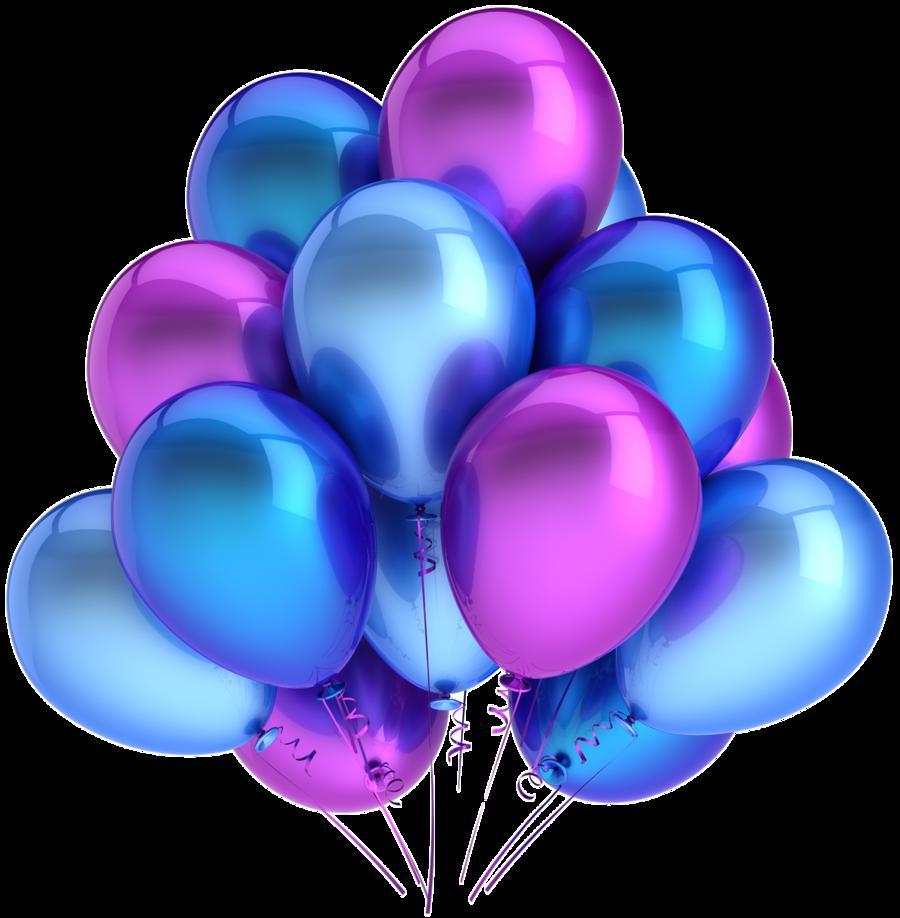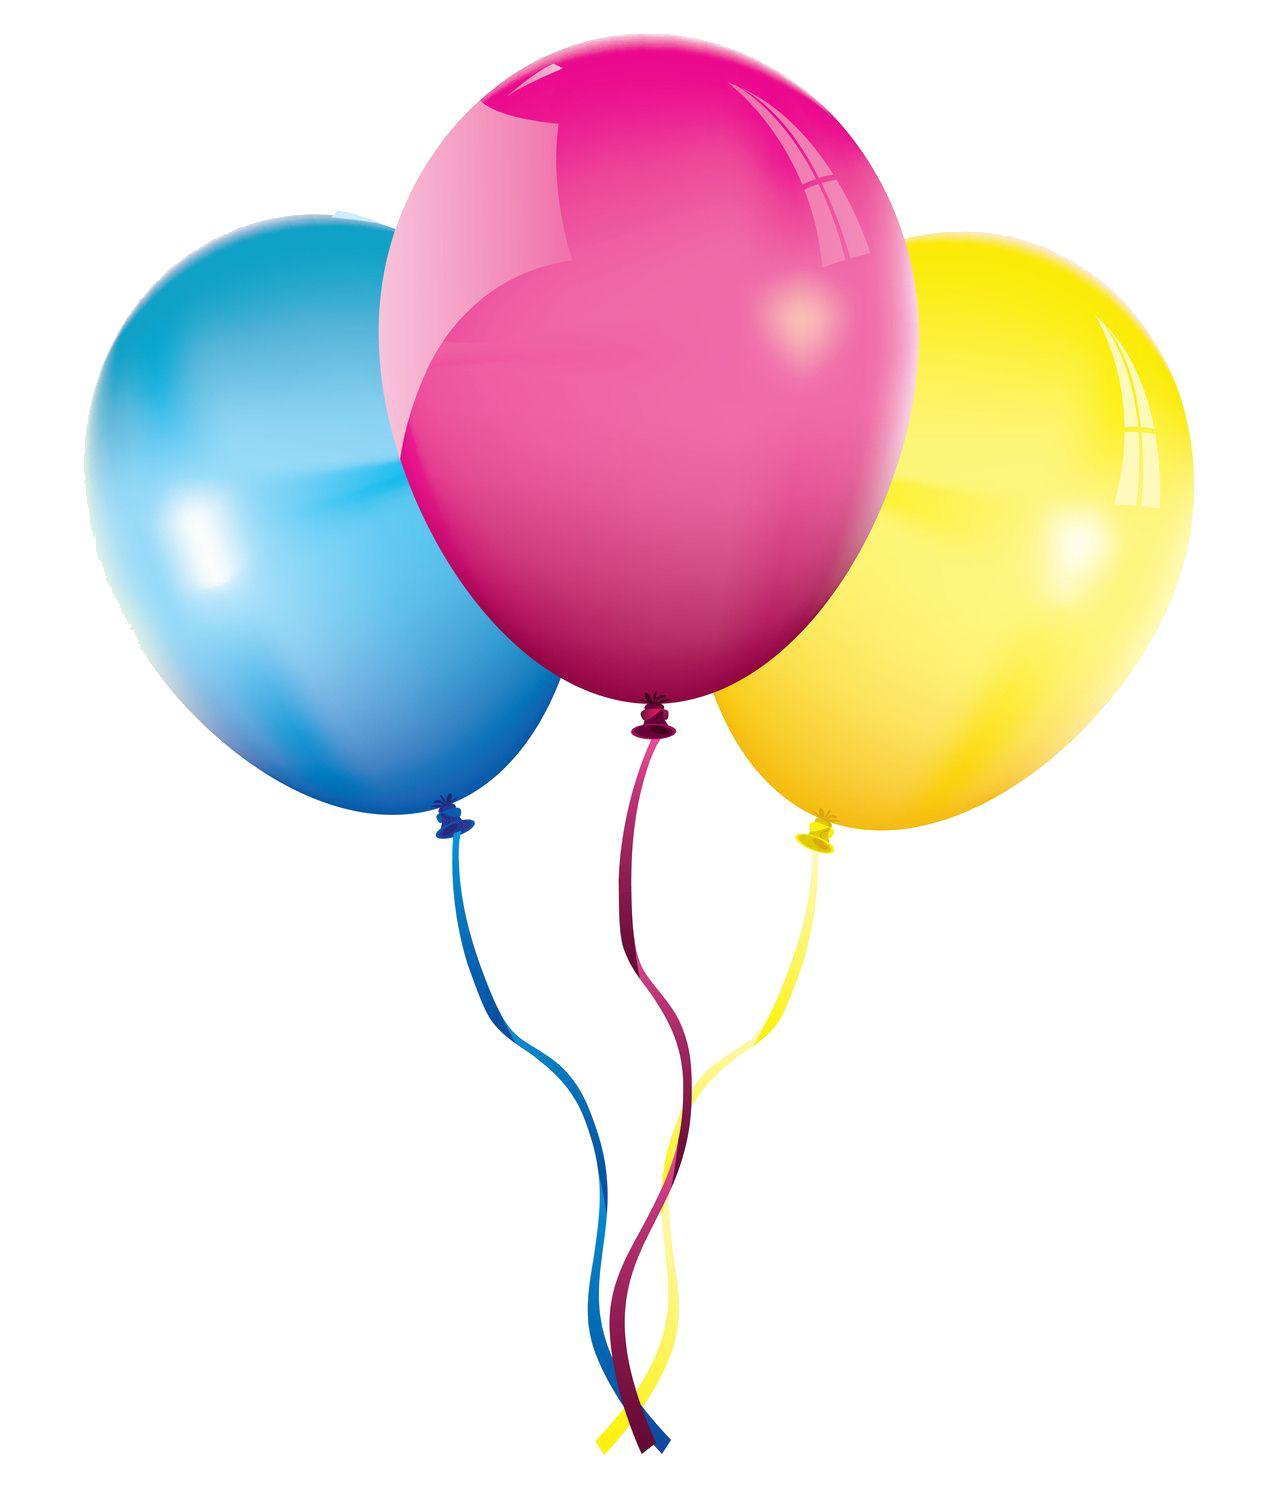The first image is the image on the left, the second image is the image on the right. For the images shown, is this caption "An image shows exactly three overlapping balloons, and one of the balloons is yellow." true? Answer yes or no. Yes. 